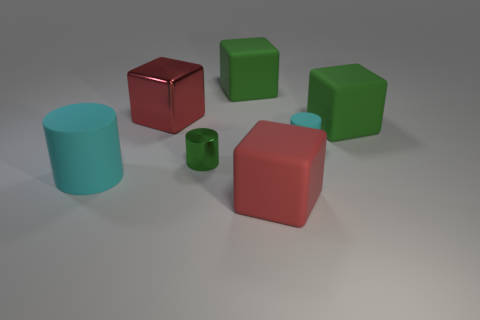Add 3 red balls. How many objects exist? 10 Subtract all big cyan rubber cylinders. How many cylinders are left? 2 Subtract all cylinders. How many objects are left? 4 Subtract 2 cylinders. How many cylinders are left? 1 Subtract all purple cubes. Subtract all blue balls. How many cubes are left? 4 Subtract all green spheres. How many green cubes are left? 2 Subtract all small green shiny cylinders. Subtract all red rubber objects. How many objects are left? 5 Add 3 green rubber things. How many green rubber things are left? 5 Add 6 metallic cylinders. How many metallic cylinders exist? 7 Subtract all green cylinders. How many cylinders are left? 2 